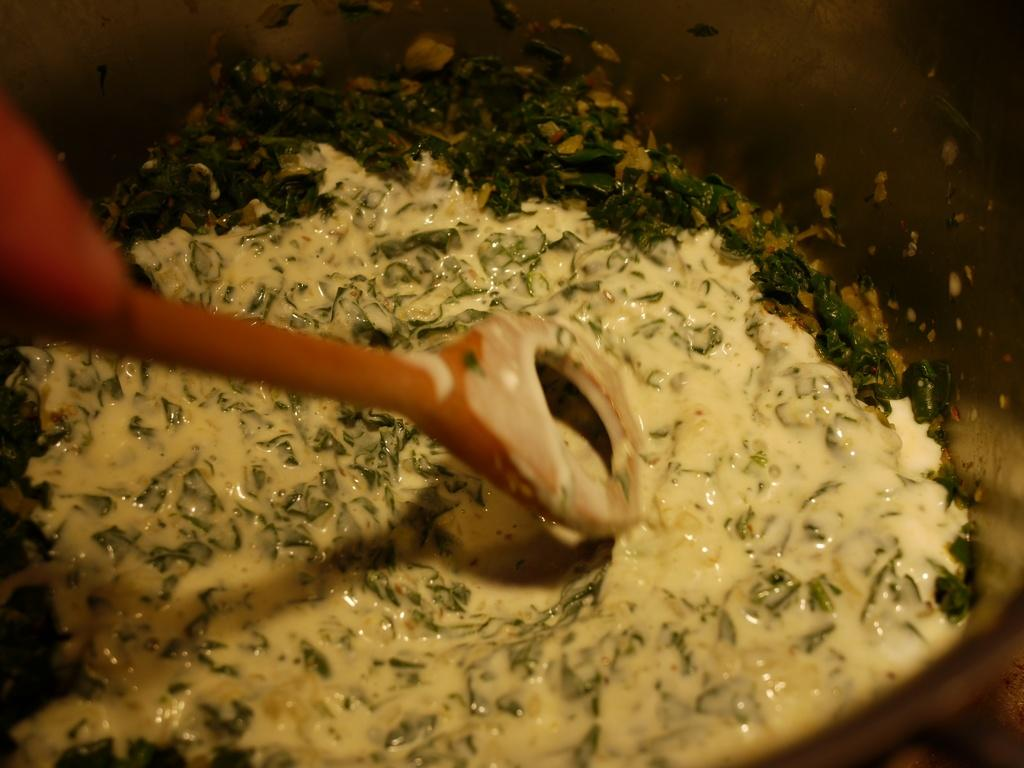What type of food is in the vessel in the image? The food in the vessel has green leaves, but the specific type of food is not mentioned. What can be used to stir or serve the food in the image? There is a wooden spoon in the front of the image. How many people are gathered in a group under the shade of the umbrella in the image? There is no mention of people, shade, or an umbrella in the image; it only features food in a vessel and a wooden spoon. 